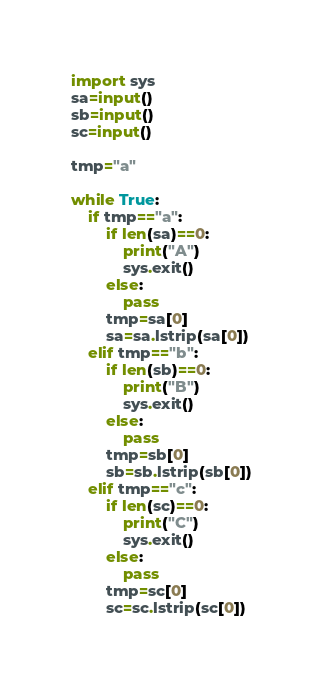Convert code to text. <code><loc_0><loc_0><loc_500><loc_500><_Python_>import sys
sa=input()
sb=input()
sc=input()

tmp="a"

while True:
    if tmp=="a":
        if len(sa)==0:
            print("A")
            sys.exit()
        else:
            pass
        tmp=sa[0]
        sa=sa.lstrip(sa[0])
    elif tmp=="b":
        if len(sb)==0:
            print("B")
            sys.exit()
        else:
            pass
        tmp=sb[0]
        sb=sb.lstrip(sb[0])
    elif tmp=="c":      
        if len(sc)==0:
            print("C")
            sys.exit()
        else:
            pass
        tmp=sc[0]
        sc=sc.lstrip(sc[0])</code> 